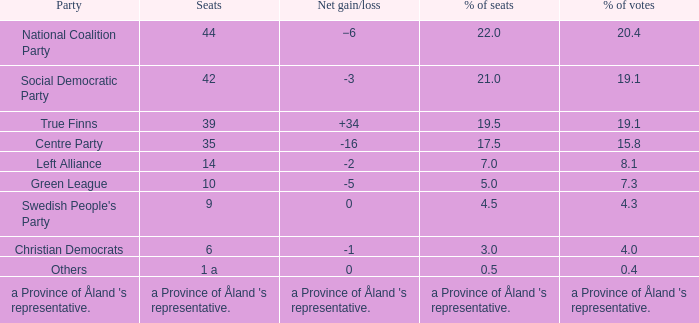What was the party's percentage of seats when they experienced a net gain/loss of +34? 19.5. Could you parse the entire table? {'header': ['Party', 'Seats', 'Net gain/loss', '% of seats', '% of votes'], 'rows': [['National Coalition Party', '44', '−6', '22.0', '20.4'], ['Social Democratic Party', '42', '-3', '21.0', '19.1'], ['True Finns', '39', '+34', '19.5', '19.1'], ['Centre Party', '35', '-16', '17.5', '15.8'], ['Left Alliance', '14', '-2', '7.0', '8.1'], ['Green League', '10', '-5', '5.0', '7.3'], ["Swedish People's Party", '9', '0', '4.5', '4.3'], ['Christian Democrats', '6', '-1', '3.0', '4.0'], ['Others', '1 a', '0', '0.5', '0.4'], ["a Province of Åland 's representative.", "a Province of Åland 's representative.", "a Province of Åland 's representative.", "a Province of Åland 's representative.", "a Province of Åland 's representative."]]} 